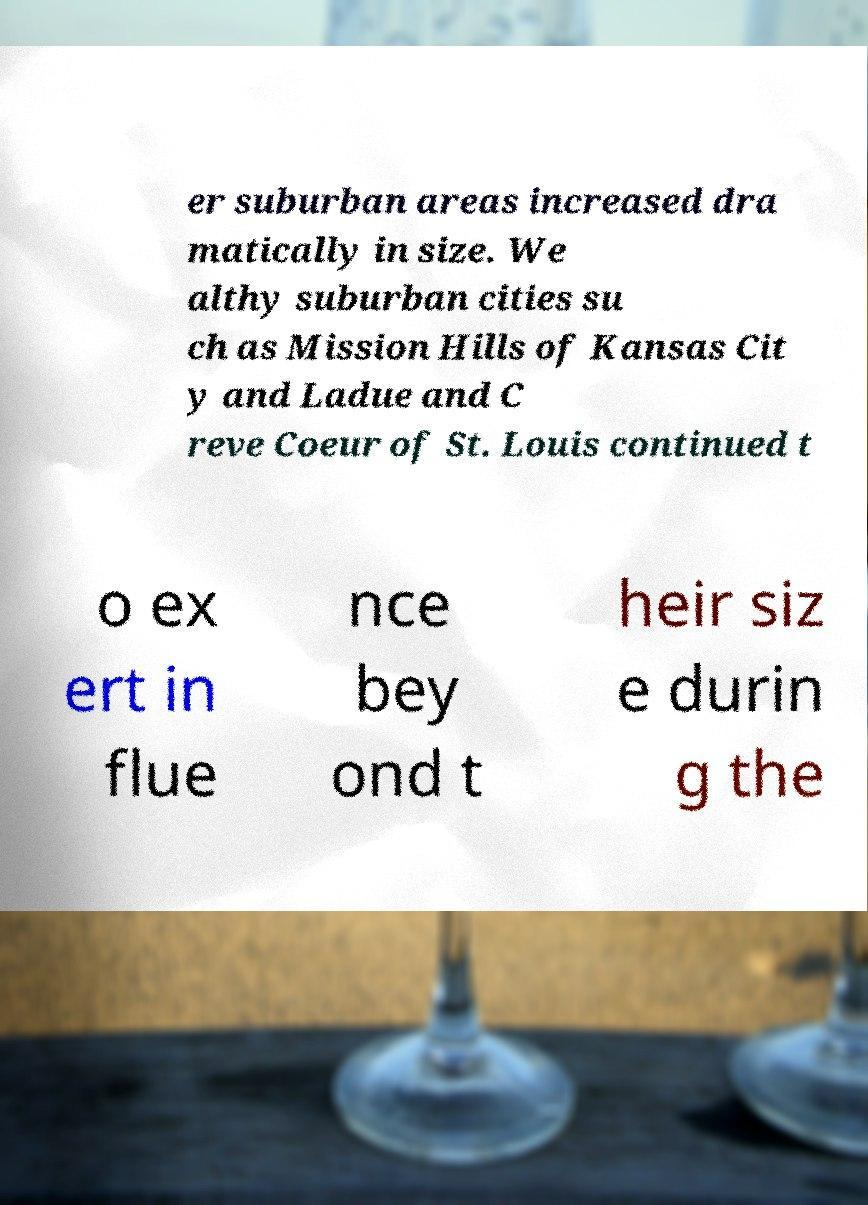Could you extract and type out the text from this image? er suburban areas increased dra matically in size. We althy suburban cities su ch as Mission Hills of Kansas Cit y and Ladue and C reve Coeur of St. Louis continued t o ex ert in flue nce bey ond t heir siz e durin g the 